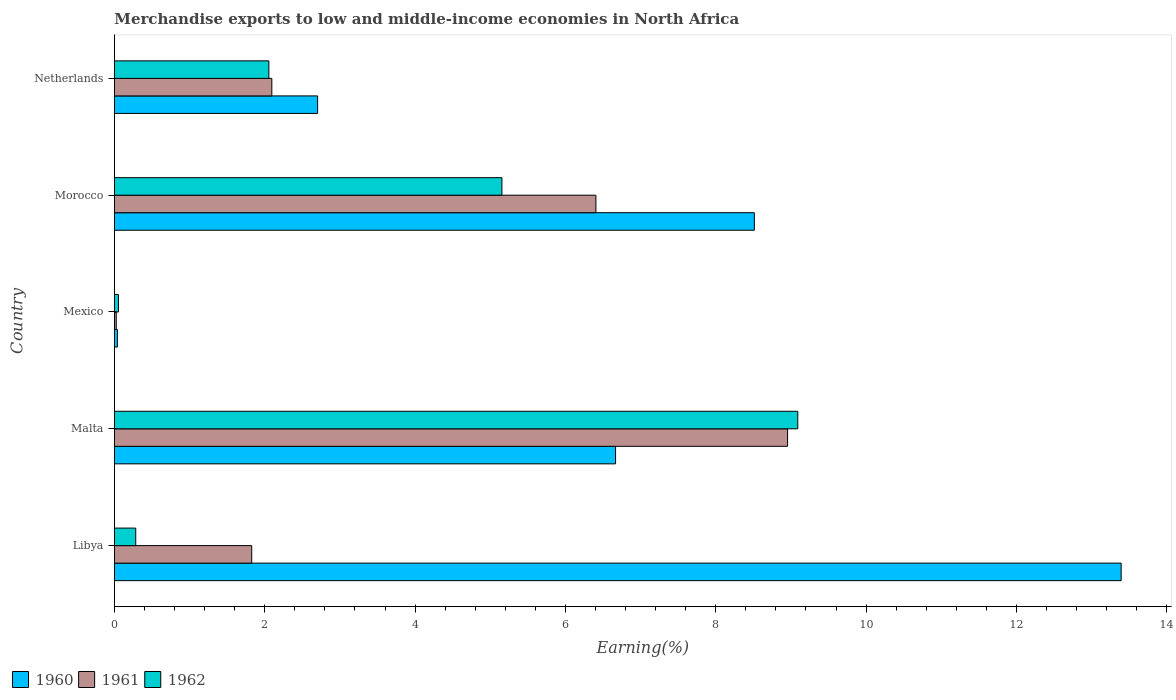How many different coloured bars are there?
Provide a short and direct response. 3. How many bars are there on the 2nd tick from the bottom?
Offer a very short reply. 3. What is the label of the 5th group of bars from the top?
Your answer should be compact. Libya. What is the percentage of amount earned from merchandise exports in 1962 in Libya?
Offer a very short reply. 0.28. Across all countries, what is the maximum percentage of amount earned from merchandise exports in 1962?
Your answer should be compact. 9.09. Across all countries, what is the minimum percentage of amount earned from merchandise exports in 1961?
Offer a terse response. 0.02. In which country was the percentage of amount earned from merchandise exports in 1961 maximum?
Offer a very short reply. Malta. What is the total percentage of amount earned from merchandise exports in 1962 in the graph?
Ensure brevity in your answer.  16.64. What is the difference between the percentage of amount earned from merchandise exports in 1960 in Libya and that in Malta?
Your answer should be compact. 6.73. What is the difference between the percentage of amount earned from merchandise exports in 1960 in Malta and the percentage of amount earned from merchandise exports in 1962 in Libya?
Offer a terse response. 6.38. What is the average percentage of amount earned from merchandise exports in 1960 per country?
Your answer should be compact. 6.26. What is the difference between the percentage of amount earned from merchandise exports in 1960 and percentage of amount earned from merchandise exports in 1962 in Libya?
Keep it short and to the point. 13.11. In how many countries, is the percentage of amount earned from merchandise exports in 1961 greater than 3.6 %?
Offer a terse response. 2. What is the ratio of the percentage of amount earned from merchandise exports in 1961 in Malta to that in Netherlands?
Your answer should be very brief. 4.28. What is the difference between the highest and the second highest percentage of amount earned from merchandise exports in 1962?
Keep it short and to the point. 3.94. What is the difference between the highest and the lowest percentage of amount earned from merchandise exports in 1962?
Ensure brevity in your answer.  9.04. In how many countries, is the percentage of amount earned from merchandise exports in 1962 greater than the average percentage of amount earned from merchandise exports in 1962 taken over all countries?
Your response must be concise. 2. Is it the case that in every country, the sum of the percentage of amount earned from merchandise exports in 1961 and percentage of amount earned from merchandise exports in 1960 is greater than the percentage of amount earned from merchandise exports in 1962?
Provide a short and direct response. Yes. What is the difference between two consecutive major ticks on the X-axis?
Your response must be concise. 2. Are the values on the major ticks of X-axis written in scientific E-notation?
Your answer should be very brief. No. Does the graph contain grids?
Your response must be concise. No. Where does the legend appear in the graph?
Give a very brief answer. Bottom left. What is the title of the graph?
Provide a succinct answer. Merchandise exports to low and middle-income economies in North Africa. Does "1964" appear as one of the legend labels in the graph?
Your answer should be compact. No. What is the label or title of the X-axis?
Ensure brevity in your answer.  Earning(%). What is the label or title of the Y-axis?
Offer a very short reply. Country. What is the Earning(%) in 1960 in Libya?
Offer a very short reply. 13.39. What is the Earning(%) of 1961 in Libya?
Keep it short and to the point. 1.83. What is the Earning(%) of 1962 in Libya?
Provide a succinct answer. 0.28. What is the Earning(%) of 1960 in Malta?
Your answer should be very brief. 6.67. What is the Earning(%) of 1961 in Malta?
Your answer should be very brief. 8.96. What is the Earning(%) in 1962 in Malta?
Keep it short and to the point. 9.09. What is the Earning(%) of 1960 in Mexico?
Offer a very short reply. 0.04. What is the Earning(%) in 1961 in Mexico?
Provide a succinct answer. 0.02. What is the Earning(%) of 1962 in Mexico?
Keep it short and to the point. 0.05. What is the Earning(%) of 1960 in Morocco?
Offer a very short reply. 8.51. What is the Earning(%) in 1961 in Morocco?
Provide a short and direct response. 6.41. What is the Earning(%) in 1962 in Morocco?
Keep it short and to the point. 5.15. What is the Earning(%) of 1960 in Netherlands?
Your answer should be very brief. 2.7. What is the Earning(%) of 1961 in Netherlands?
Give a very brief answer. 2.09. What is the Earning(%) of 1962 in Netherlands?
Provide a short and direct response. 2.05. Across all countries, what is the maximum Earning(%) in 1960?
Offer a very short reply. 13.39. Across all countries, what is the maximum Earning(%) of 1961?
Provide a succinct answer. 8.96. Across all countries, what is the maximum Earning(%) in 1962?
Offer a terse response. 9.09. Across all countries, what is the minimum Earning(%) in 1960?
Keep it short and to the point. 0.04. Across all countries, what is the minimum Earning(%) in 1961?
Provide a succinct answer. 0.02. Across all countries, what is the minimum Earning(%) of 1962?
Give a very brief answer. 0.05. What is the total Earning(%) of 1960 in the graph?
Provide a short and direct response. 31.31. What is the total Earning(%) in 1961 in the graph?
Provide a succinct answer. 19.31. What is the total Earning(%) in 1962 in the graph?
Provide a succinct answer. 16.64. What is the difference between the Earning(%) of 1960 in Libya and that in Malta?
Your answer should be compact. 6.73. What is the difference between the Earning(%) in 1961 in Libya and that in Malta?
Your response must be concise. -7.13. What is the difference between the Earning(%) in 1962 in Libya and that in Malta?
Make the answer very short. -8.81. What is the difference between the Earning(%) in 1960 in Libya and that in Mexico?
Your response must be concise. 13.35. What is the difference between the Earning(%) in 1961 in Libya and that in Mexico?
Make the answer very short. 1.8. What is the difference between the Earning(%) in 1962 in Libya and that in Mexico?
Your answer should be compact. 0.23. What is the difference between the Earning(%) of 1960 in Libya and that in Morocco?
Provide a short and direct response. 4.88. What is the difference between the Earning(%) of 1961 in Libya and that in Morocco?
Give a very brief answer. -4.58. What is the difference between the Earning(%) of 1962 in Libya and that in Morocco?
Provide a succinct answer. -4.87. What is the difference between the Earning(%) in 1960 in Libya and that in Netherlands?
Ensure brevity in your answer.  10.69. What is the difference between the Earning(%) of 1961 in Libya and that in Netherlands?
Provide a succinct answer. -0.27. What is the difference between the Earning(%) of 1962 in Libya and that in Netherlands?
Provide a succinct answer. -1.77. What is the difference between the Earning(%) of 1960 in Malta and that in Mexico?
Your answer should be compact. 6.63. What is the difference between the Earning(%) of 1961 in Malta and that in Mexico?
Your answer should be very brief. 8.93. What is the difference between the Earning(%) of 1962 in Malta and that in Mexico?
Offer a terse response. 9.04. What is the difference between the Earning(%) in 1960 in Malta and that in Morocco?
Offer a very short reply. -1.85. What is the difference between the Earning(%) of 1961 in Malta and that in Morocco?
Provide a short and direct response. 2.55. What is the difference between the Earning(%) in 1962 in Malta and that in Morocco?
Your answer should be compact. 3.94. What is the difference between the Earning(%) of 1960 in Malta and that in Netherlands?
Keep it short and to the point. 3.96. What is the difference between the Earning(%) in 1961 in Malta and that in Netherlands?
Offer a very short reply. 6.86. What is the difference between the Earning(%) in 1962 in Malta and that in Netherlands?
Your response must be concise. 7.04. What is the difference between the Earning(%) in 1960 in Mexico and that in Morocco?
Make the answer very short. -8.47. What is the difference between the Earning(%) of 1961 in Mexico and that in Morocco?
Provide a succinct answer. -6.38. What is the difference between the Earning(%) in 1962 in Mexico and that in Morocco?
Make the answer very short. -5.1. What is the difference between the Earning(%) in 1960 in Mexico and that in Netherlands?
Offer a very short reply. -2.66. What is the difference between the Earning(%) of 1961 in Mexico and that in Netherlands?
Provide a short and direct response. -2.07. What is the difference between the Earning(%) in 1962 in Mexico and that in Netherlands?
Your response must be concise. -2. What is the difference between the Earning(%) of 1960 in Morocco and that in Netherlands?
Your response must be concise. 5.81. What is the difference between the Earning(%) of 1961 in Morocco and that in Netherlands?
Provide a succinct answer. 4.31. What is the difference between the Earning(%) in 1962 in Morocco and that in Netherlands?
Keep it short and to the point. 3.1. What is the difference between the Earning(%) of 1960 in Libya and the Earning(%) of 1961 in Malta?
Your response must be concise. 4.44. What is the difference between the Earning(%) of 1960 in Libya and the Earning(%) of 1962 in Malta?
Give a very brief answer. 4.3. What is the difference between the Earning(%) of 1961 in Libya and the Earning(%) of 1962 in Malta?
Provide a short and direct response. -7.26. What is the difference between the Earning(%) of 1960 in Libya and the Earning(%) of 1961 in Mexico?
Offer a terse response. 13.37. What is the difference between the Earning(%) in 1960 in Libya and the Earning(%) in 1962 in Mexico?
Your answer should be compact. 13.34. What is the difference between the Earning(%) in 1961 in Libya and the Earning(%) in 1962 in Mexico?
Your answer should be very brief. 1.77. What is the difference between the Earning(%) of 1960 in Libya and the Earning(%) of 1961 in Morocco?
Make the answer very short. 6.99. What is the difference between the Earning(%) of 1960 in Libya and the Earning(%) of 1962 in Morocco?
Your response must be concise. 8.24. What is the difference between the Earning(%) of 1961 in Libya and the Earning(%) of 1962 in Morocco?
Your answer should be compact. -3.33. What is the difference between the Earning(%) of 1960 in Libya and the Earning(%) of 1961 in Netherlands?
Your answer should be compact. 11.3. What is the difference between the Earning(%) in 1960 in Libya and the Earning(%) in 1962 in Netherlands?
Provide a succinct answer. 11.34. What is the difference between the Earning(%) of 1961 in Libya and the Earning(%) of 1962 in Netherlands?
Make the answer very short. -0.23. What is the difference between the Earning(%) of 1960 in Malta and the Earning(%) of 1961 in Mexico?
Offer a very short reply. 6.64. What is the difference between the Earning(%) of 1960 in Malta and the Earning(%) of 1962 in Mexico?
Keep it short and to the point. 6.61. What is the difference between the Earning(%) in 1961 in Malta and the Earning(%) in 1962 in Mexico?
Your response must be concise. 8.9. What is the difference between the Earning(%) of 1960 in Malta and the Earning(%) of 1961 in Morocco?
Keep it short and to the point. 0.26. What is the difference between the Earning(%) in 1960 in Malta and the Earning(%) in 1962 in Morocco?
Ensure brevity in your answer.  1.51. What is the difference between the Earning(%) in 1961 in Malta and the Earning(%) in 1962 in Morocco?
Keep it short and to the point. 3.8. What is the difference between the Earning(%) of 1960 in Malta and the Earning(%) of 1961 in Netherlands?
Keep it short and to the point. 4.57. What is the difference between the Earning(%) in 1960 in Malta and the Earning(%) in 1962 in Netherlands?
Your response must be concise. 4.61. What is the difference between the Earning(%) in 1961 in Malta and the Earning(%) in 1962 in Netherlands?
Ensure brevity in your answer.  6.9. What is the difference between the Earning(%) of 1960 in Mexico and the Earning(%) of 1961 in Morocco?
Keep it short and to the point. -6.37. What is the difference between the Earning(%) of 1960 in Mexico and the Earning(%) of 1962 in Morocco?
Offer a very short reply. -5.12. What is the difference between the Earning(%) of 1961 in Mexico and the Earning(%) of 1962 in Morocco?
Your answer should be very brief. -5.13. What is the difference between the Earning(%) in 1960 in Mexico and the Earning(%) in 1961 in Netherlands?
Your response must be concise. -2.05. What is the difference between the Earning(%) in 1960 in Mexico and the Earning(%) in 1962 in Netherlands?
Provide a short and direct response. -2.02. What is the difference between the Earning(%) of 1961 in Mexico and the Earning(%) of 1962 in Netherlands?
Provide a short and direct response. -2.03. What is the difference between the Earning(%) in 1960 in Morocco and the Earning(%) in 1961 in Netherlands?
Make the answer very short. 6.42. What is the difference between the Earning(%) in 1960 in Morocco and the Earning(%) in 1962 in Netherlands?
Your response must be concise. 6.46. What is the difference between the Earning(%) of 1961 in Morocco and the Earning(%) of 1962 in Netherlands?
Offer a terse response. 4.35. What is the average Earning(%) of 1960 per country?
Your response must be concise. 6.26. What is the average Earning(%) of 1961 per country?
Provide a short and direct response. 3.86. What is the average Earning(%) of 1962 per country?
Your answer should be very brief. 3.33. What is the difference between the Earning(%) in 1960 and Earning(%) in 1961 in Libya?
Keep it short and to the point. 11.57. What is the difference between the Earning(%) in 1960 and Earning(%) in 1962 in Libya?
Your answer should be compact. 13.11. What is the difference between the Earning(%) of 1961 and Earning(%) of 1962 in Libya?
Provide a succinct answer. 1.54. What is the difference between the Earning(%) in 1960 and Earning(%) in 1961 in Malta?
Ensure brevity in your answer.  -2.29. What is the difference between the Earning(%) in 1960 and Earning(%) in 1962 in Malta?
Give a very brief answer. -2.42. What is the difference between the Earning(%) of 1961 and Earning(%) of 1962 in Malta?
Your response must be concise. -0.14. What is the difference between the Earning(%) in 1960 and Earning(%) in 1961 in Mexico?
Your answer should be compact. 0.01. What is the difference between the Earning(%) of 1960 and Earning(%) of 1962 in Mexico?
Offer a terse response. -0.01. What is the difference between the Earning(%) of 1961 and Earning(%) of 1962 in Mexico?
Give a very brief answer. -0.03. What is the difference between the Earning(%) of 1960 and Earning(%) of 1961 in Morocco?
Provide a succinct answer. 2.11. What is the difference between the Earning(%) of 1960 and Earning(%) of 1962 in Morocco?
Make the answer very short. 3.36. What is the difference between the Earning(%) in 1961 and Earning(%) in 1962 in Morocco?
Your answer should be very brief. 1.25. What is the difference between the Earning(%) in 1960 and Earning(%) in 1961 in Netherlands?
Keep it short and to the point. 0.61. What is the difference between the Earning(%) in 1960 and Earning(%) in 1962 in Netherlands?
Your response must be concise. 0.65. What is the difference between the Earning(%) of 1961 and Earning(%) of 1962 in Netherlands?
Offer a terse response. 0.04. What is the ratio of the Earning(%) in 1960 in Libya to that in Malta?
Your answer should be very brief. 2.01. What is the ratio of the Earning(%) in 1961 in Libya to that in Malta?
Your answer should be very brief. 0.2. What is the ratio of the Earning(%) in 1962 in Libya to that in Malta?
Offer a terse response. 0.03. What is the ratio of the Earning(%) of 1960 in Libya to that in Mexico?
Make the answer very short. 341.25. What is the ratio of the Earning(%) in 1961 in Libya to that in Mexico?
Ensure brevity in your answer.  75.4. What is the ratio of the Earning(%) of 1962 in Libya to that in Mexico?
Provide a short and direct response. 5.28. What is the ratio of the Earning(%) in 1960 in Libya to that in Morocco?
Offer a very short reply. 1.57. What is the ratio of the Earning(%) of 1961 in Libya to that in Morocco?
Provide a short and direct response. 0.29. What is the ratio of the Earning(%) of 1962 in Libya to that in Morocco?
Give a very brief answer. 0.06. What is the ratio of the Earning(%) of 1960 in Libya to that in Netherlands?
Give a very brief answer. 4.95. What is the ratio of the Earning(%) in 1961 in Libya to that in Netherlands?
Your response must be concise. 0.87. What is the ratio of the Earning(%) of 1962 in Libya to that in Netherlands?
Make the answer very short. 0.14. What is the ratio of the Earning(%) in 1960 in Malta to that in Mexico?
Make the answer very short. 169.87. What is the ratio of the Earning(%) of 1961 in Malta to that in Mexico?
Give a very brief answer. 369.67. What is the ratio of the Earning(%) in 1962 in Malta to that in Mexico?
Provide a succinct answer. 169.22. What is the ratio of the Earning(%) of 1960 in Malta to that in Morocco?
Your answer should be very brief. 0.78. What is the ratio of the Earning(%) of 1961 in Malta to that in Morocco?
Offer a terse response. 1.4. What is the ratio of the Earning(%) of 1962 in Malta to that in Morocco?
Make the answer very short. 1.76. What is the ratio of the Earning(%) of 1960 in Malta to that in Netherlands?
Offer a very short reply. 2.47. What is the ratio of the Earning(%) of 1961 in Malta to that in Netherlands?
Offer a very short reply. 4.28. What is the ratio of the Earning(%) in 1962 in Malta to that in Netherlands?
Offer a very short reply. 4.42. What is the ratio of the Earning(%) of 1960 in Mexico to that in Morocco?
Provide a short and direct response. 0. What is the ratio of the Earning(%) of 1961 in Mexico to that in Morocco?
Make the answer very short. 0. What is the ratio of the Earning(%) of 1962 in Mexico to that in Morocco?
Keep it short and to the point. 0.01. What is the ratio of the Earning(%) in 1960 in Mexico to that in Netherlands?
Ensure brevity in your answer.  0.01. What is the ratio of the Earning(%) of 1961 in Mexico to that in Netherlands?
Offer a very short reply. 0.01. What is the ratio of the Earning(%) of 1962 in Mexico to that in Netherlands?
Provide a short and direct response. 0.03. What is the ratio of the Earning(%) in 1960 in Morocco to that in Netherlands?
Provide a short and direct response. 3.15. What is the ratio of the Earning(%) of 1961 in Morocco to that in Netherlands?
Give a very brief answer. 3.06. What is the ratio of the Earning(%) of 1962 in Morocco to that in Netherlands?
Give a very brief answer. 2.51. What is the difference between the highest and the second highest Earning(%) in 1960?
Make the answer very short. 4.88. What is the difference between the highest and the second highest Earning(%) in 1961?
Offer a very short reply. 2.55. What is the difference between the highest and the second highest Earning(%) in 1962?
Provide a short and direct response. 3.94. What is the difference between the highest and the lowest Earning(%) in 1960?
Ensure brevity in your answer.  13.35. What is the difference between the highest and the lowest Earning(%) in 1961?
Keep it short and to the point. 8.93. What is the difference between the highest and the lowest Earning(%) of 1962?
Provide a succinct answer. 9.04. 